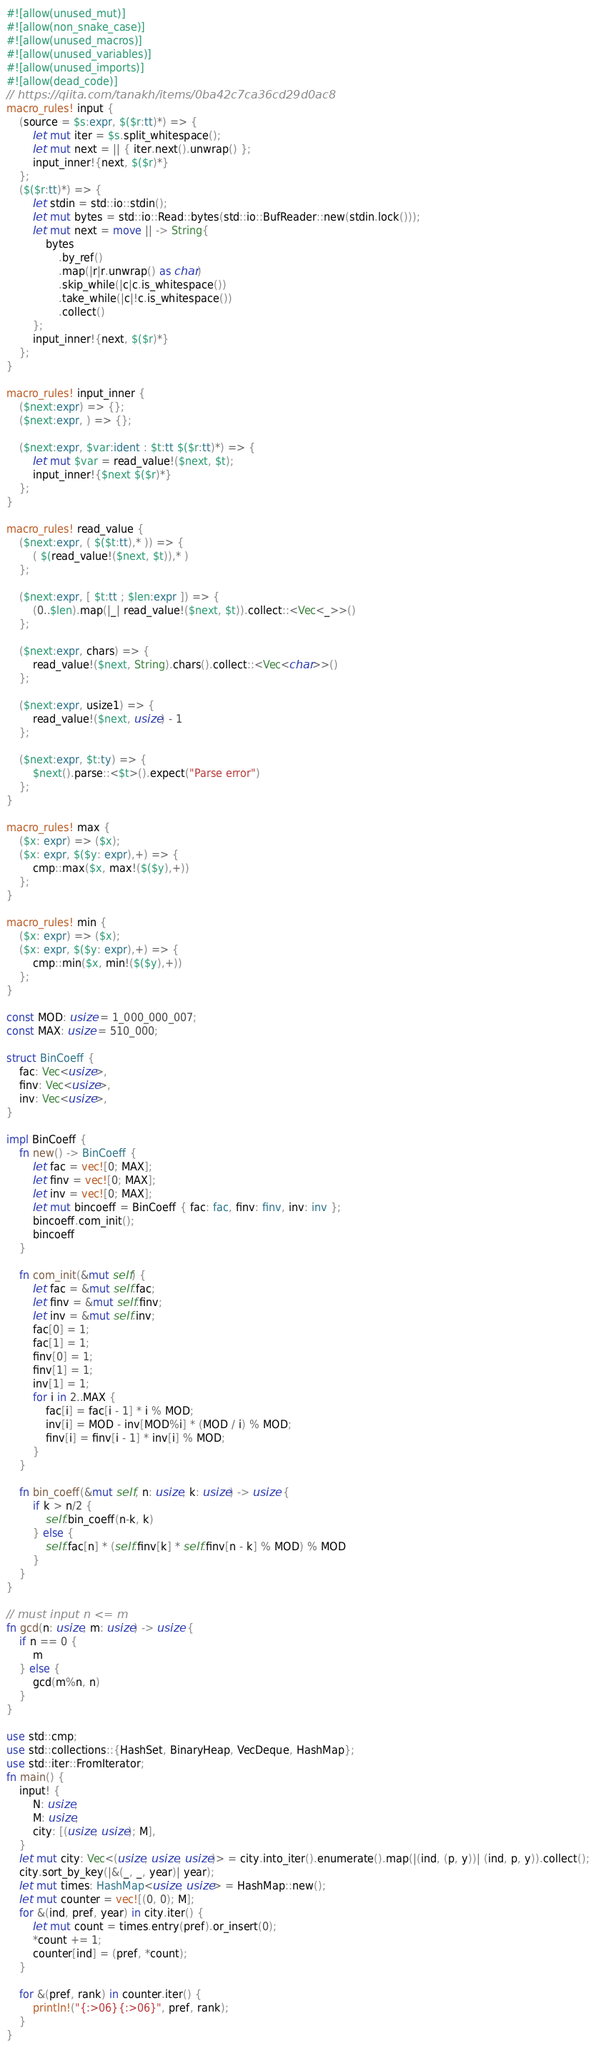<code> <loc_0><loc_0><loc_500><loc_500><_Rust_>#![allow(unused_mut)]
#![allow(non_snake_case)]
#![allow(unused_macros)]
#![allow(unused_variables)]
#![allow(unused_imports)]
#![allow(dead_code)]
// https://qiita.com/tanakh/items/0ba42c7ca36cd29d0ac8
macro_rules! input {
    (source = $s:expr, $($r:tt)*) => {
        let mut iter = $s.split_whitespace();
        let mut next = || { iter.next().unwrap() };
        input_inner!{next, $($r)*}
    };
    ($($r:tt)*) => {
        let stdin = std::io::stdin();
        let mut bytes = std::io::Read::bytes(std::io::BufReader::new(stdin.lock()));
        let mut next = move || -> String{
            bytes
                .by_ref()
                .map(|r|r.unwrap() as char)
                .skip_while(|c|c.is_whitespace())
                .take_while(|c|!c.is_whitespace())
                .collect()
        };
        input_inner!{next, $($r)*}
    };
}

macro_rules! input_inner {
    ($next:expr) => {};
    ($next:expr, ) => {};

    ($next:expr, $var:ident : $t:tt $($r:tt)*) => {
        let mut $var = read_value!($next, $t);
        input_inner!{$next $($r)*}
    };
}

macro_rules! read_value {
    ($next:expr, ( $($t:tt),* )) => {
        ( $(read_value!($next, $t)),* )
    };

    ($next:expr, [ $t:tt ; $len:expr ]) => {
        (0..$len).map(|_| read_value!($next, $t)).collect::<Vec<_>>()
    };

    ($next:expr, chars) => {
        read_value!($next, String).chars().collect::<Vec<char>>()
    };

    ($next:expr, usize1) => {
        read_value!($next, usize) - 1
    };

    ($next:expr, $t:ty) => {
        $next().parse::<$t>().expect("Parse error")
    };
}

macro_rules! max {
    ($x: expr) => ($x);
    ($x: expr, $($y: expr),+) => {
        cmp::max($x, max!($($y),+))
    };
}

macro_rules! min {
    ($x: expr) => ($x);
    ($x: expr, $($y: expr),+) => {
        cmp::min($x, min!($($y),+))
    };
}

const MOD: usize = 1_000_000_007;
const MAX: usize = 510_000;

struct BinCoeff {
    fac: Vec<usize>,
    finv: Vec<usize>,
    inv: Vec<usize>,
}

impl BinCoeff {
    fn new() -> BinCoeff {
        let fac = vec![0; MAX];
        let finv = vec![0; MAX];
        let inv = vec![0; MAX];
        let mut bincoeff = BinCoeff { fac: fac, finv: finv, inv: inv };
        bincoeff.com_init();
        bincoeff
    }

    fn com_init(&mut self) {
        let fac = &mut self.fac;
        let finv = &mut self.finv;
        let inv = &mut self.inv;
        fac[0] = 1;
        fac[1] = 1;
        finv[0] = 1;
        finv[1] = 1;
        inv[1] = 1;
        for i in 2..MAX {
            fac[i] = fac[i - 1] * i % MOD;
            inv[i] = MOD - inv[MOD%i] * (MOD / i) % MOD;
            finv[i] = finv[i - 1] * inv[i] % MOD;
        }
    }

    fn bin_coeff(&mut self, n: usize, k: usize) -> usize {
        if k > n/2 {
            self.bin_coeff(n-k, k)
        } else {
            self.fac[n] * (self.finv[k] * self.finv[n - k] % MOD) % MOD
        }
    }
}

// must input n <= m
fn gcd(n: usize, m: usize) -> usize {
    if n == 0 {
        m
    } else {
        gcd(m%n, n)
    }
}

use std::cmp;
use std::collections::{HashSet, BinaryHeap, VecDeque, HashMap};
use std::iter::FromIterator;
fn main() {
    input! {
        N: usize,
        M: usize,
        city: [(usize, usize); M],
    }
    let mut city: Vec<(usize, usize, usize)> = city.into_iter().enumerate().map(|(ind, (p, y))| (ind, p, y)).collect();
    city.sort_by_key(|&(_, _, year)| year);
    let mut times: HashMap<usize, usize> = HashMap::new();
    let mut counter = vec![(0, 0); M];
    for &(ind, pref, year) in city.iter() {
        let mut count = times.entry(pref).or_insert(0);
        *count += 1;
        counter[ind] = (pref, *count);
    }

    for &(pref, rank) in counter.iter() {
        println!("{:>06}{:>06}", pref, rank);
    }
}
</code> 